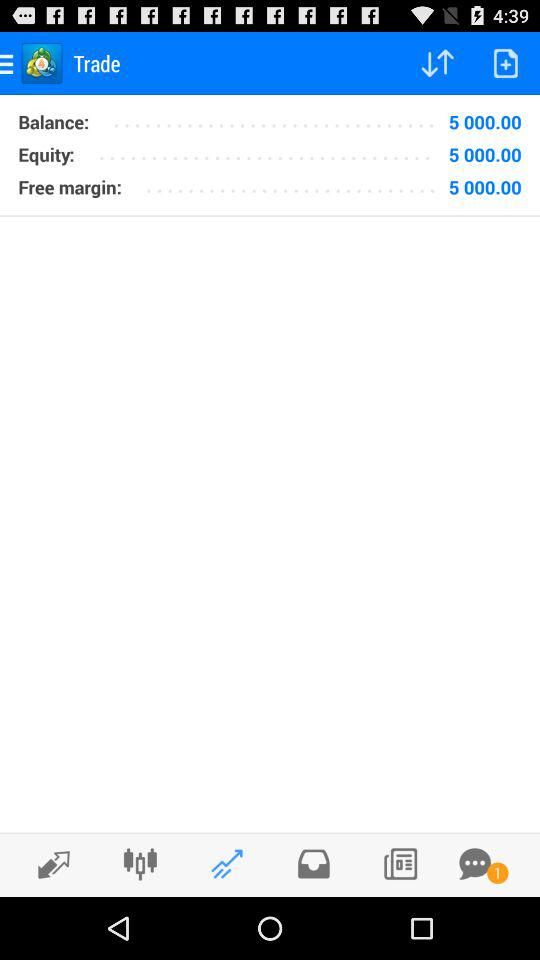What is the balance? The balance is 5,000.00. 